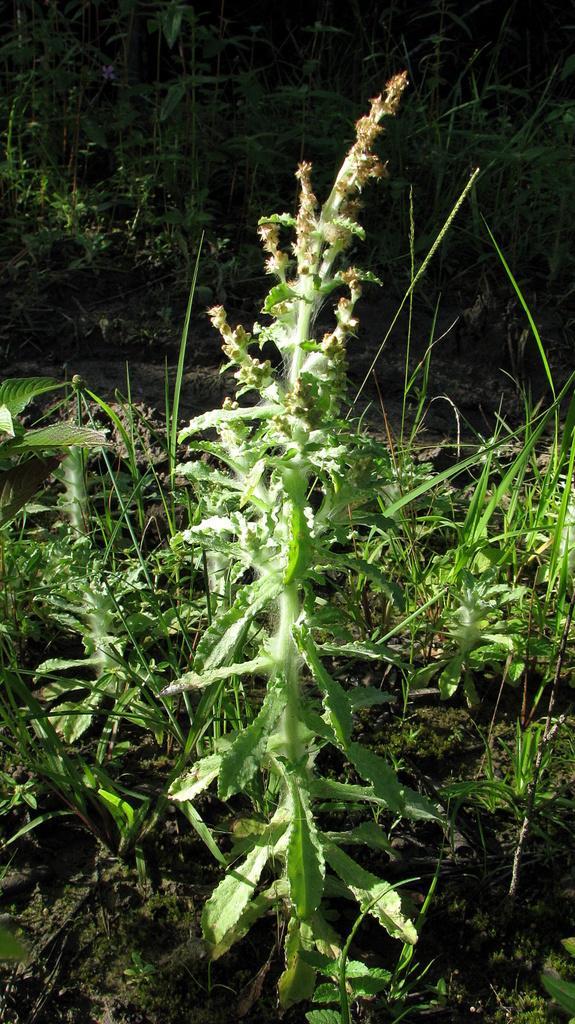Describe this image in one or two sentences. In the center of this picture we can see the plants and the grass. In the background we can see the plants and the ground. 